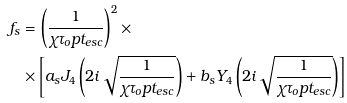<formula> <loc_0><loc_0><loc_500><loc_500>f _ { s } & = \left ( \frac { 1 } { \chi \tau _ { o } p t _ { e s c } } \right ) ^ { 2 } \times \\ & \times \left [ a _ { s } J _ { 4 } \left ( 2 i \sqrt { \frac { 1 } { \chi \tau _ { o } p t _ { e s c } } } \right ) + b _ { s } Y _ { 4 } \left ( 2 i \sqrt { \frac { 1 } { \chi \tau _ { o } p t _ { e s c } } } \right ) \right ]</formula> 